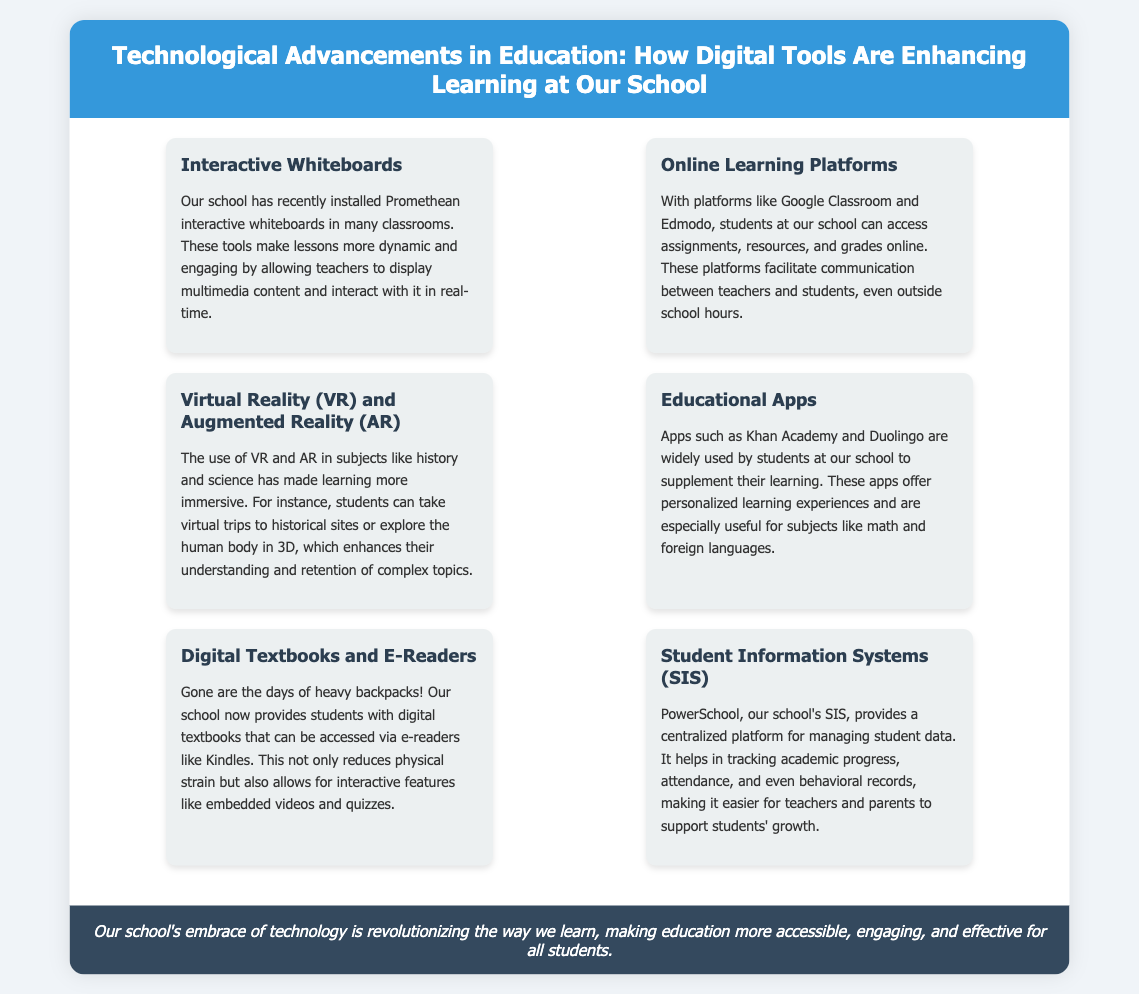What tools have been installed in classrooms? The document states that Promethean interactive whiteboards have been installed in many classrooms.
Answer: Promethean interactive whiteboards What platforms facilitate communication between teachers and students? The document mentions Google Classroom and Edmodo as platforms that facilitate communication.
Answer: Google Classroom and Edmodo Which subjects benefit from Virtual Reality and Augmented Reality? The document indicates that VR and AR are used in subjects like history and science.
Answer: History and science Name one educational app mentioned in the document. The document lists Khan Academy and Duolingo as widely used educational apps.
Answer: Khan Academy What does PowerSchool help manage? According to the document, PowerSchool provides a centralized platform for managing student data, including academic progress and attendance.
Answer: Student data How have digital textbooks impacted students' backpacks? The document explains that digital textbooks reduce the physical strain associated with heavy backpacks.
Answer: Reduced physical strain What is the purpose of the Student Information Systems? The document describes the SIS as aiding in tracking academic progress, attendance, and behavioral records.
Answer: Tracking academic progress, attendance, and behavioral records What is a benefit of using apps like Khan Academy? The document states that these apps offer personalized learning experiences to supplement learning.
Answer: Personalized learning experiences 